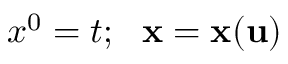Convert formula to latex. <formula><loc_0><loc_0><loc_500><loc_500>x ^ { 0 } = t ; { x } = { x } ( { u } )</formula> 